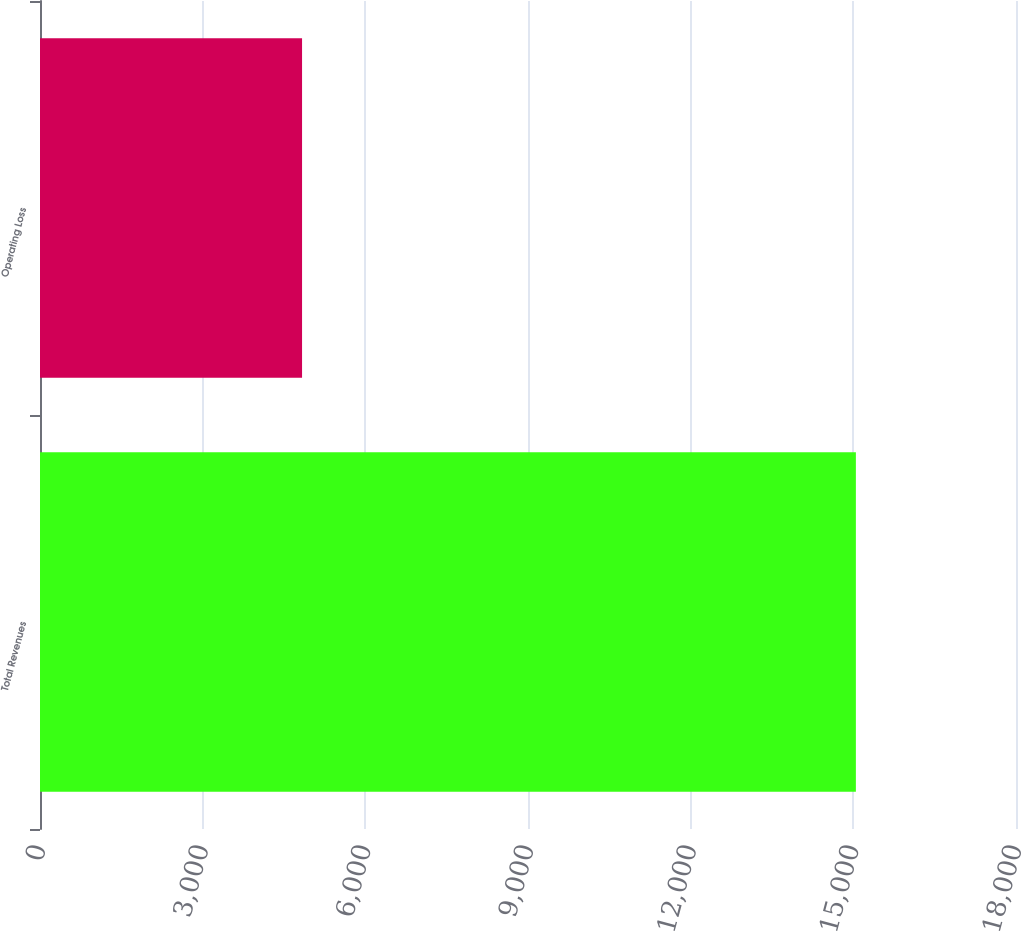<chart> <loc_0><loc_0><loc_500><loc_500><bar_chart><fcel>Total Revenues<fcel>Operating Loss<nl><fcel>15047<fcel>4833<nl></chart> 